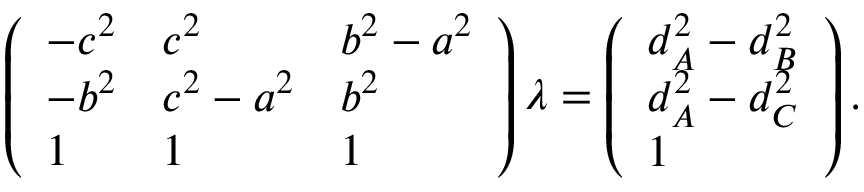Convert formula to latex. <formula><loc_0><loc_0><loc_500><loc_500>\left ( { \begin{array} { l l l } { - c ^ { 2 } } & { c ^ { 2 } } & { b ^ { 2 } - a ^ { 2 } } \\ { - b ^ { 2 } } & { c ^ { 2 } - a ^ { 2 } } & { b ^ { 2 } } \\ { 1 } & { 1 } & { 1 } \end{array} } \right ) { \lambda } = \left ( { \begin{array} { l } { d _ { A } ^ { 2 } - d _ { B } ^ { 2 } } \\ { d _ { A } ^ { 2 } - d _ { C } ^ { 2 } } \\ { 1 } \end{array} } \right ) .</formula> 